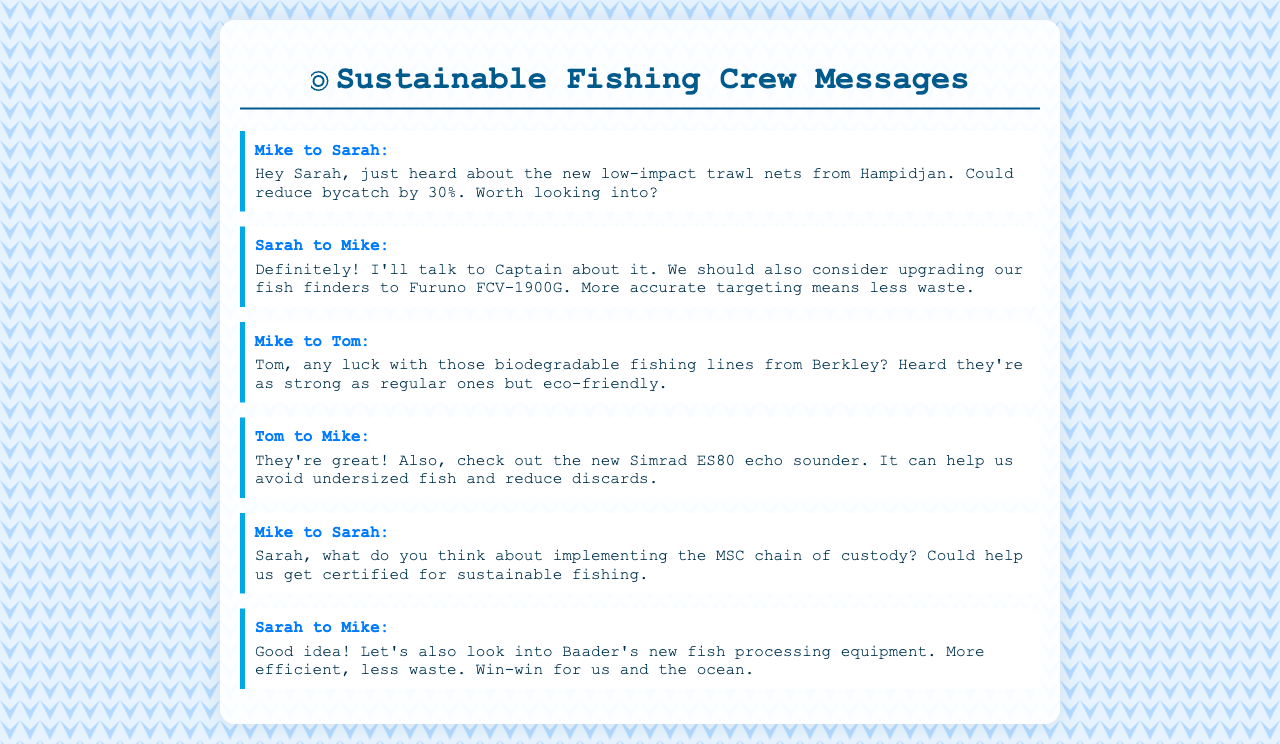what new fishing equipment is mentioned? Mike mentions new low-impact trawl nets from Hampidjan to reduce bycatch and Sarah suggests upgrading to Furuno FCV-1900G fish finders.
Answer: low-impact trawl nets, Furuno FCV-1900G who talks about biodegradable fishing lines? Mike asks Tom about the biodegradable fishing lines from Berkley and Tom responds positively.
Answer: Tom what percentage can bycatch be reduced by the new trawl nets? Mike states that the new low-impact trawl nets could reduce bycatch by 30%.
Answer: 30% what is the suggested new echo sounder? Tom recommends the new Simrad ES80 echo sounder.
Answer: Simrad ES80 what certification does Mike propose implementing? Mike suggests implementing the MSC chain of custody for sustainable fishing certification.
Answer: MSC chain of custody which company’s fish processing equipment did Sarah mention? Sarah mentions looking into Baader's new fish processing equipment.
Answer: Baader what is the main topic of the crew messages? The crew messages focus on discussing sustainable fishing practices and equipment upgrades.
Answer: sustainable fishing practices how does Sarah describe the potential of new fish processing equipment? Sarah refers to the new equipment as more efficient and leads to less waste.
Answer: more efficient, less waste 